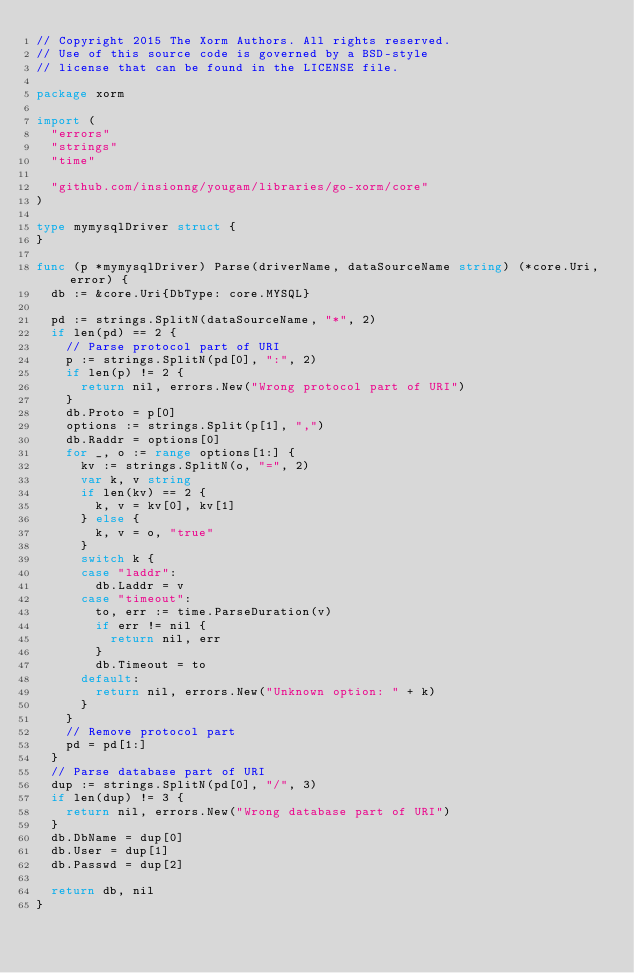<code> <loc_0><loc_0><loc_500><loc_500><_Go_>// Copyright 2015 The Xorm Authors. All rights reserved.
// Use of this source code is governed by a BSD-style
// license that can be found in the LICENSE file.

package xorm

import (
	"errors"
	"strings"
	"time"

	"github.com/insionng/yougam/libraries/go-xorm/core"
)

type mymysqlDriver struct {
}

func (p *mymysqlDriver) Parse(driverName, dataSourceName string) (*core.Uri, error) {
	db := &core.Uri{DbType: core.MYSQL}

	pd := strings.SplitN(dataSourceName, "*", 2)
	if len(pd) == 2 {
		// Parse protocol part of URI
		p := strings.SplitN(pd[0], ":", 2)
		if len(p) != 2 {
			return nil, errors.New("Wrong protocol part of URI")
		}
		db.Proto = p[0]
		options := strings.Split(p[1], ",")
		db.Raddr = options[0]
		for _, o := range options[1:] {
			kv := strings.SplitN(o, "=", 2)
			var k, v string
			if len(kv) == 2 {
				k, v = kv[0], kv[1]
			} else {
				k, v = o, "true"
			}
			switch k {
			case "laddr":
				db.Laddr = v
			case "timeout":
				to, err := time.ParseDuration(v)
				if err != nil {
					return nil, err
				}
				db.Timeout = to
			default:
				return nil, errors.New("Unknown option: " + k)
			}
		}
		// Remove protocol part
		pd = pd[1:]
	}
	// Parse database part of URI
	dup := strings.SplitN(pd[0], "/", 3)
	if len(dup) != 3 {
		return nil, errors.New("Wrong database part of URI")
	}
	db.DbName = dup[0]
	db.User = dup[1]
	db.Passwd = dup[2]

	return db, nil
}
</code> 